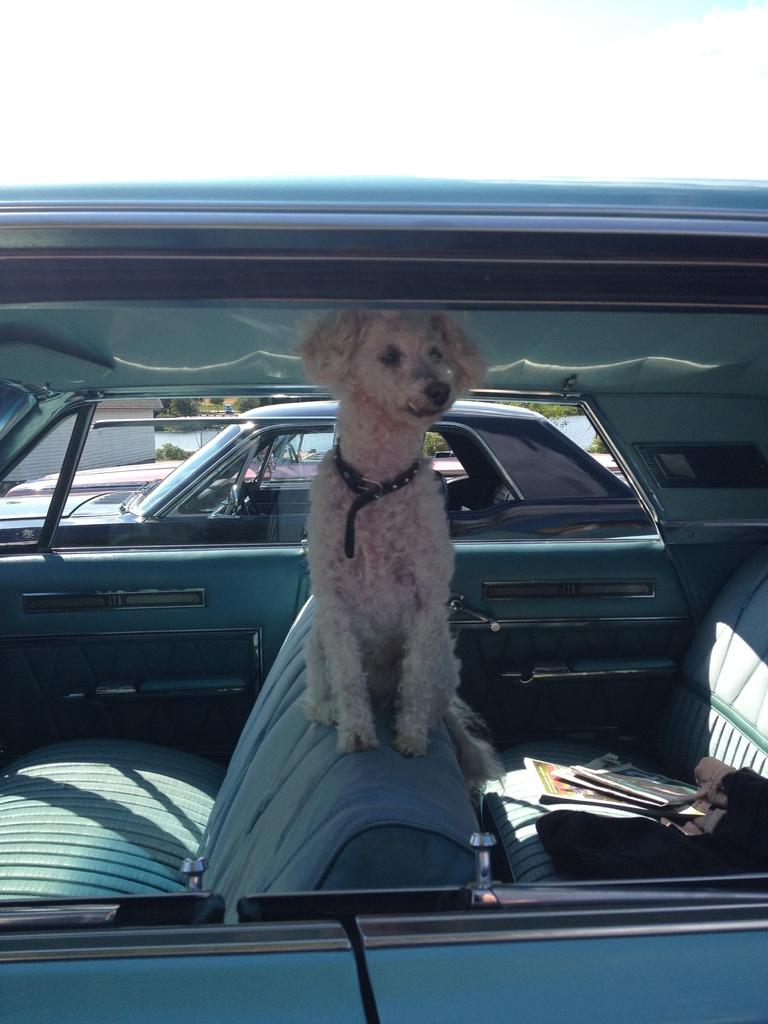What animal can be seen in the picture? There is a dog in the picture. Where is the dog located? The dog is sitting inside a car. What else is inside the car? There is a bag and a paper inside the car. What can be seen beside the car? There is another vehicle beside the car. What type of police copy can be seen on the branch outside the car? There is no police copy or branch present in the image. 